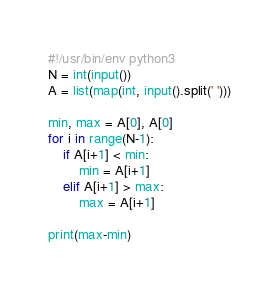<code> <loc_0><loc_0><loc_500><loc_500><_Python_>#!/usr/bin/env python3
N = int(input())
A = list(map(int, input().split(' ')))

min, max = A[0], A[0]
for i in range(N-1):
    if A[i+1] < min:
        min = A[i+1]
    elif A[i+1] > max:
        max = A[i+1]

print(max-min)</code> 